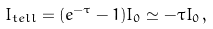<formula> <loc_0><loc_0><loc_500><loc_500>I _ { t e l l } = ( e ^ { - \tau } - 1 ) I _ { 0 } \simeq - \tau I _ { 0 } \, ,</formula> 